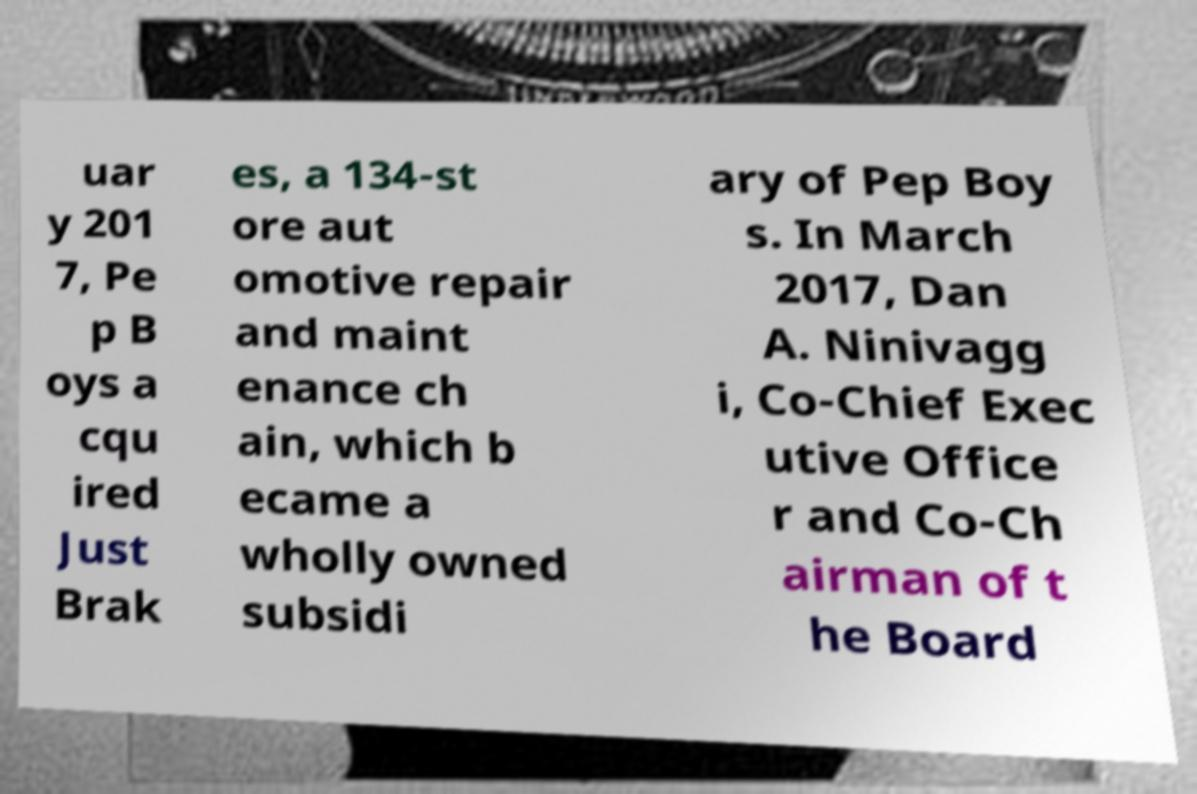Can you read and provide the text displayed in the image?This photo seems to have some interesting text. Can you extract and type it out for me? uar y 201 7, Pe p B oys a cqu ired Just Brak es, a 134-st ore aut omotive repair and maint enance ch ain, which b ecame a wholly owned subsidi ary of Pep Boy s. In March 2017, Dan A. Ninivagg i, Co-Chief Exec utive Office r and Co-Ch airman of t he Board 